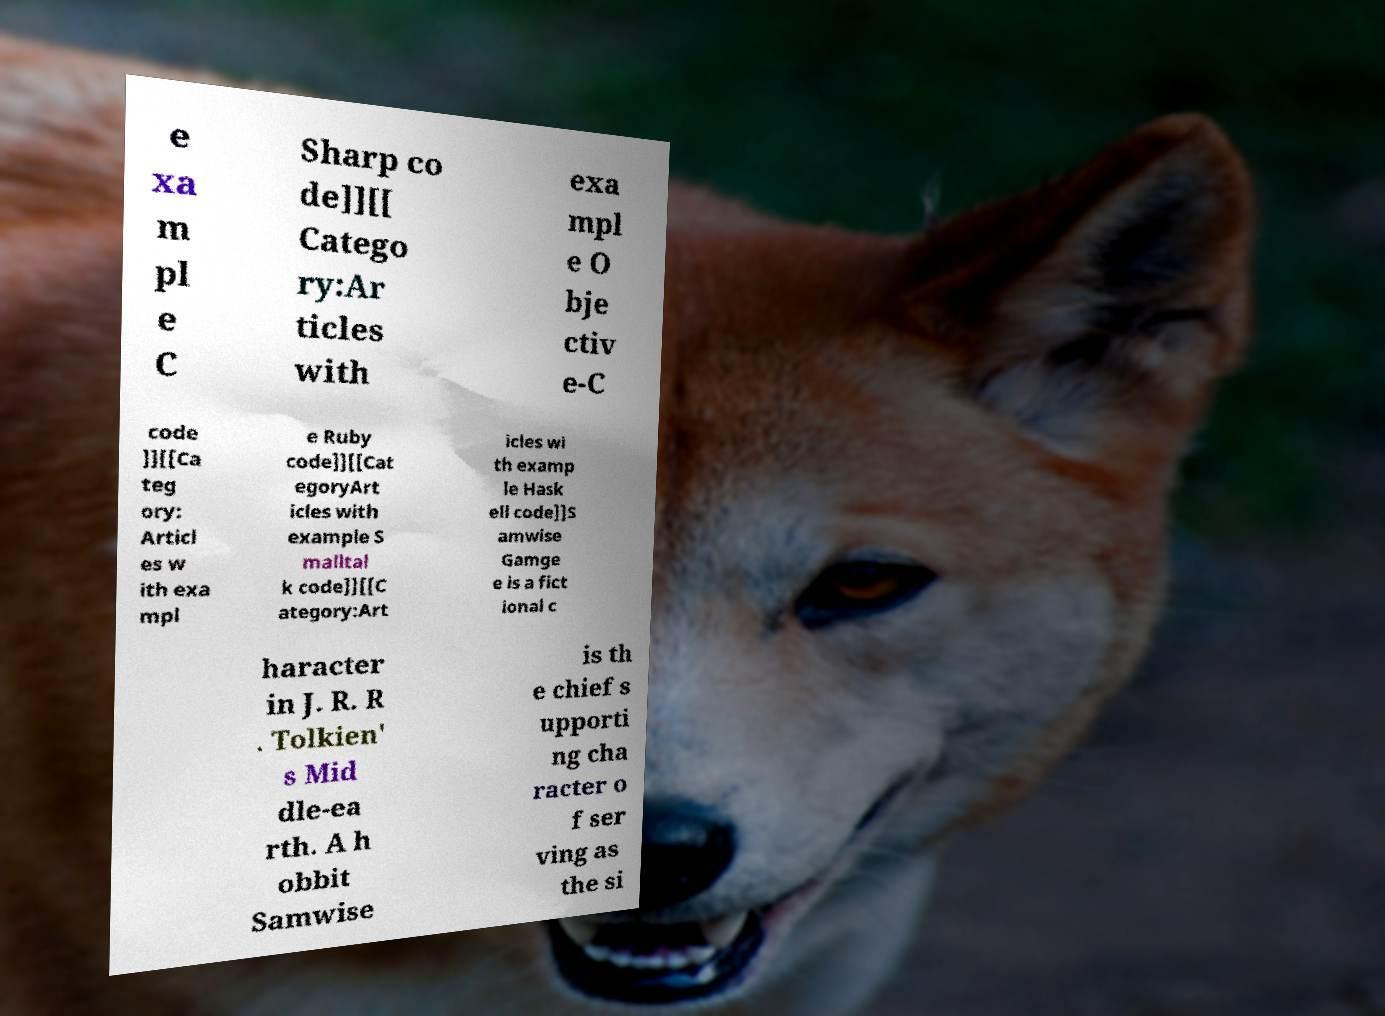Please identify and transcribe the text found in this image. e xa m pl e C Sharp co de]][[ Catego ry:Ar ticles with exa mpl e O bje ctiv e-C code ]][[Ca teg ory: Articl es w ith exa mpl e Ruby code]][[Cat egoryArt icles with example S malltal k code]][[C ategory:Art icles wi th examp le Hask ell code]]S amwise Gamge e is a fict ional c haracter in J. R. R . Tolkien' s Mid dle-ea rth. A h obbit Samwise is th e chief s upporti ng cha racter o f ser ving as the si 